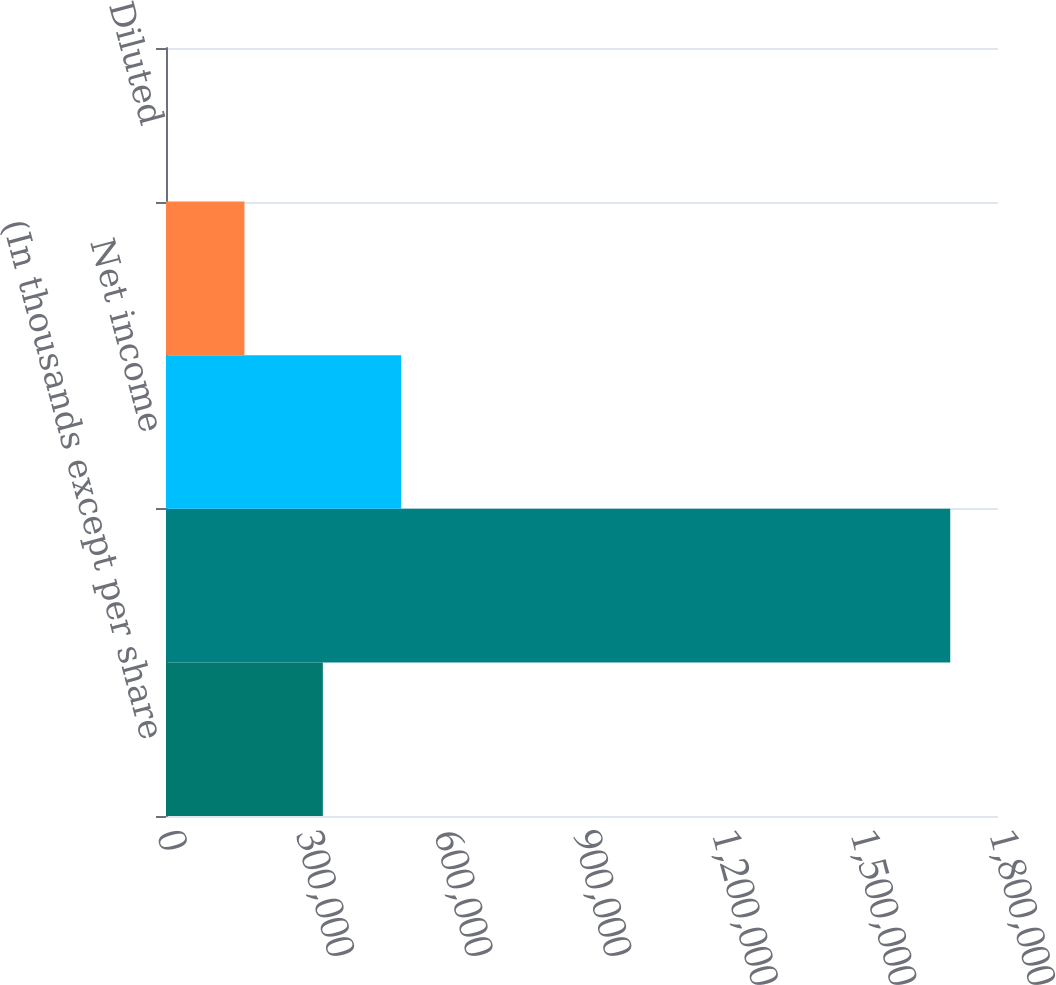Convert chart to OTSL. <chart><loc_0><loc_0><loc_500><loc_500><bar_chart><fcel>(In thousands except per share<fcel>Revenues<fcel>Net income<fcel>Basic<fcel>Diluted<nl><fcel>339337<fcel>1.69668e+06<fcel>509004<fcel>169669<fcel>0.93<nl></chart> 